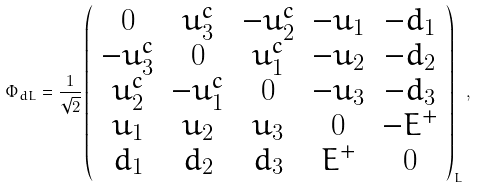Convert formula to latex. <formula><loc_0><loc_0><loc_500><loc_500>\Phi _ { d L } = \frac { 1 } { \sqrt { 2 } } \left ( \begin{array} { c c c c c } 0 & u ^ { c } _ { 3 } & - u ^ { c } _ { 2 } & - u _ { 1 } & - d _ { 1 } \\ - u ^ { c } _ { 3 } & 0 & u ^ { c } _ { 1 } & - u _ { 2 } & - d _ { 2 } \\ u ^ { c } _ { 2 } & - u ^ { c } _ { 1 } & 0 & - u _ { 3 } & - d _ { 3 } \\ u _ { 1 } & u _ { 2 } & u _ { 3 } & 0 & - E ^ { + } \\ d _ { 1 } & d _ { 2 } & d _ { 3 } & E ^ { + } & 0 \end{array} \right ) _ { L } ,</formula> 